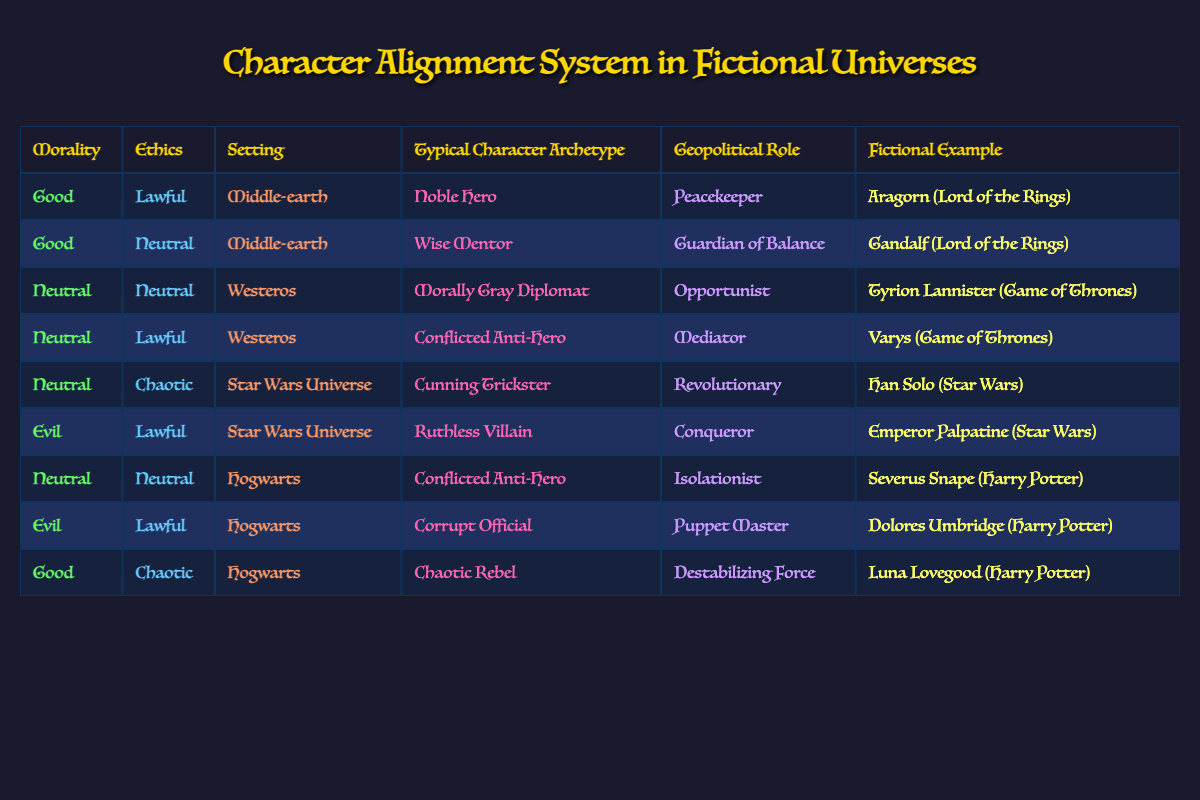What is the typical character archetype for a Good, Lawful character in Middle-earth? According to the table, the row that corresponds to a Good, Lawful character in Middle-earth indicates that the typical character archetype is "Noble Hero."
Answer: Noble Hero Which character serves as a Wise Mentor in Middle-earth? The table shows that Gandalf, who fits the criteria of a Good, Neutral character in Middle-earth, is identified as a Wise Mentor.
Answer: Gandalf (Lord of the Rings) Is Tyrion Lannister considered a Peacekeeper in Westeros? By examining the table, Tyrion Lannister is classified as a Morally Gray Diplomat and an Opportunist, not a Peacekeeper. Therefore, the answer is no.
Answer: No How many characters in the table are classified as Evil? A quick scan through the "Morality" column reveals three instances labeled as Evil: Emperor Palpatine, Dolores Umbridge, and the entry for Evil, Lawful in the Star Wars Universe and Hogwarts settings. Therefore, there are three characters.
Answer: 3 What character from Hogwarts can be classified as a Chaotic Rebel? The table indicates that Luna Lovegood matches the criteria of a Good, Chaotic character in Hogwarts, recognized as a Chaotic Rebel.
Answer: Luna Lovegood (Harry Potter) Which character archetype has the role of a Conqueror? Referring to the table, it shows that Emperor Palpatine from the Star Wars Universe is classified as a Ruthless Villain and holds the geopolitical role of a Conqueror.
Answer: Ruthless Villain Does the setting of Middle-earth have a character labeled as a Neutral Observer? Upon reviewing the table, no characters are identified as a Neutral Observer in the Middle-earth setting, so the statement is false.
Answer: No Identify the characters associated with the role of an Isolationist in Hogwarts. The table indicates that Severus Snape is listed as a Conflicted Anti-Hero who plays the role of an Isolationist, aligning with the Neutral, Neutral category in Hogwarts.
Answer: Severus Snape (Harry Potter) What is the difference in character roles between a Morally Gray Diplomat and a Conflicted Anti-Hero in Westeros? The table lists Tyrion Lannister as a Morally Gray Diplomat and Varys as a Conflicted Anti-Hero, with the former being categorized as an Opportunist and the latter as a Mediator. This indicates different approaches to navigating the political landscape, focusing on opportunism versus mediation.
Answer: Opportunist vs. Mediator 